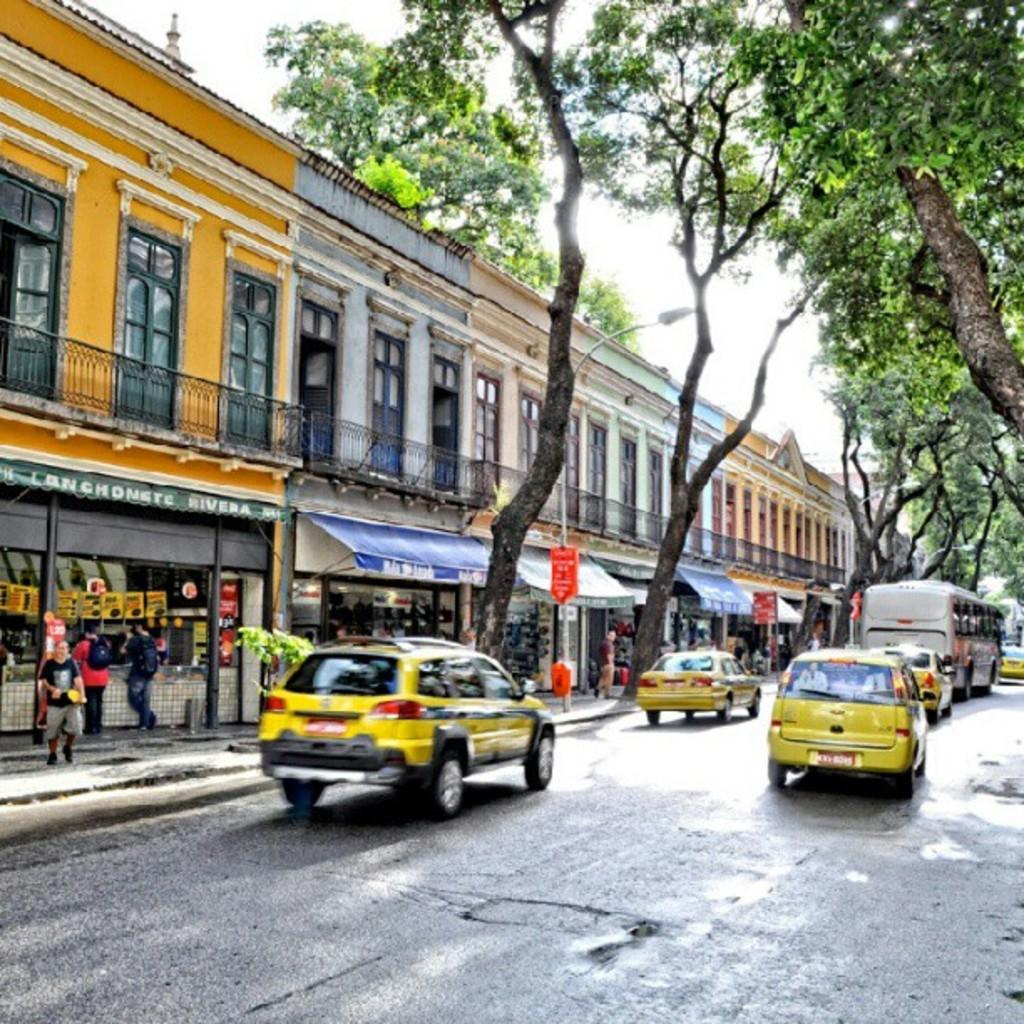<image>
Write a terse but informative summary of the picture. Among several stores lining a moderately busy street, one of the canopies contains the word Rivera. 